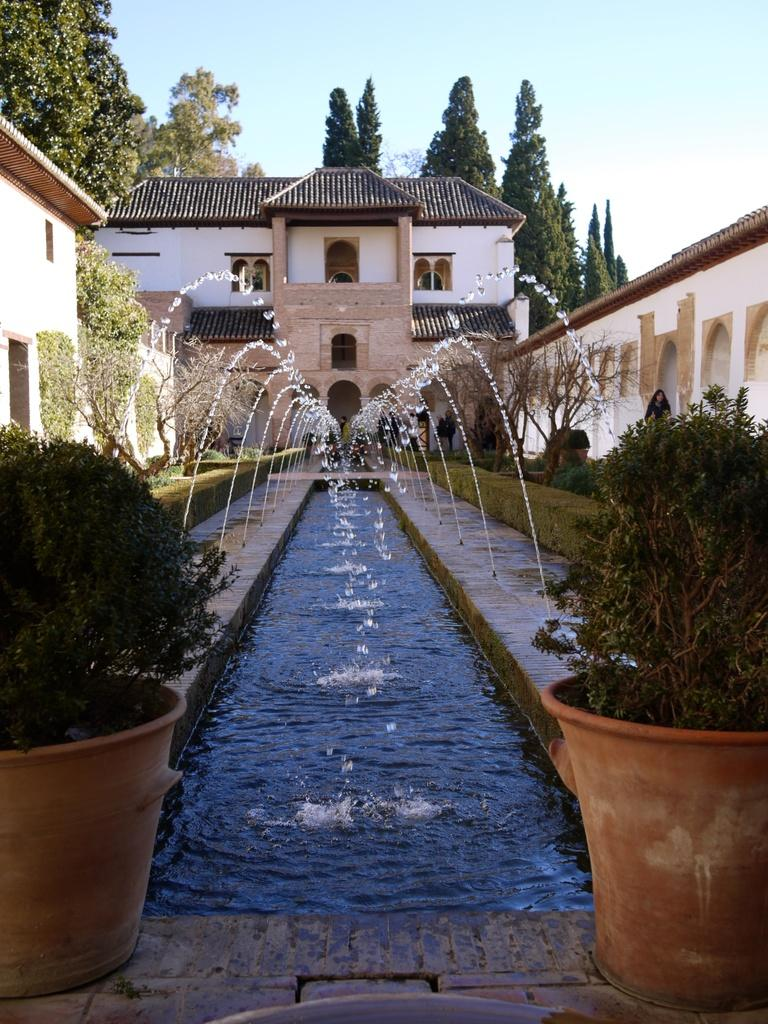What is the primary element visible in the image? There is water in the image. What other natural elements can be seen in the image? There are plants, trees, and the sky visible in the image. What man-made structures are present in the image? There are buildings in the image. What type of containers are visible in the image? There are pots in the image. What color of paint is being used on the church in the image? There is no church present in the image, so it is not possible to determine the color of paint being used. How many corks can be seen floating in the water in the image? There are no corks visible in the image; it features water, plants, trees, buildings, and pots. 